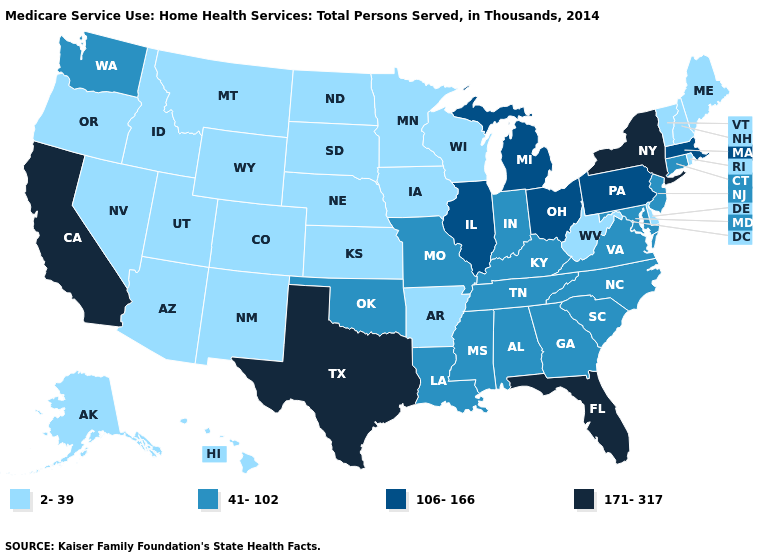What is the value of California?
Short answer required. 171-317. What is the value of Colorado?
Be succinct. 2-39. Which states have the lowest value in the USA?
Concise answer only. Alaska, Arizona, Arkansas, Colorado, Delaware, Hawaii, Idaho, Iowa, Kansas, Maine, Minnesota, Montana, Nebraska, Nevada, New Hampshire, New Mexico, North Dakota, Oregon, Rhode Island, South Dakota, Utah, Vermont, West Virginia, Wisconsin, Wyoming. Name the states that have a value in the range 41-102?
Quick response, please. Alabama, Connecticut, Georgia, Indiana, Kentucky, Louisiana, Maryland, Mississippi, Missouri, New Jersey, North Carolina, Oklahoma, South Carolina, Tennessee, Virginia, Washington. What is the value of Oregon?
Answer briefly. 2-39. How many symbols are there in the legend?
Keep it brief. 4. Name the states that have a value in the range 171-317?
Be succinct. California, Florida, New York, Texas. How many symbols are there in the legend?
Concise answer only. 4. Name the states that have a value in the range 106-166?
Write a very short answer. Illinois, Massachusetts, Michigan, Ohio, Pennsylvania. Does Alaska have the same value as Iowa?
Concise answer only. Yes. How many symbols are there in the legend?
Quick response, please. 4. What is the value of Oregon?
Short answer required. 2-39. What is the value of Nevada?
Write a very short answer. 2-39. Does Washington have the lowest value in the USA?
Give a very brief answer. No. What is the value of California?
Quick response, please. 171-317. 